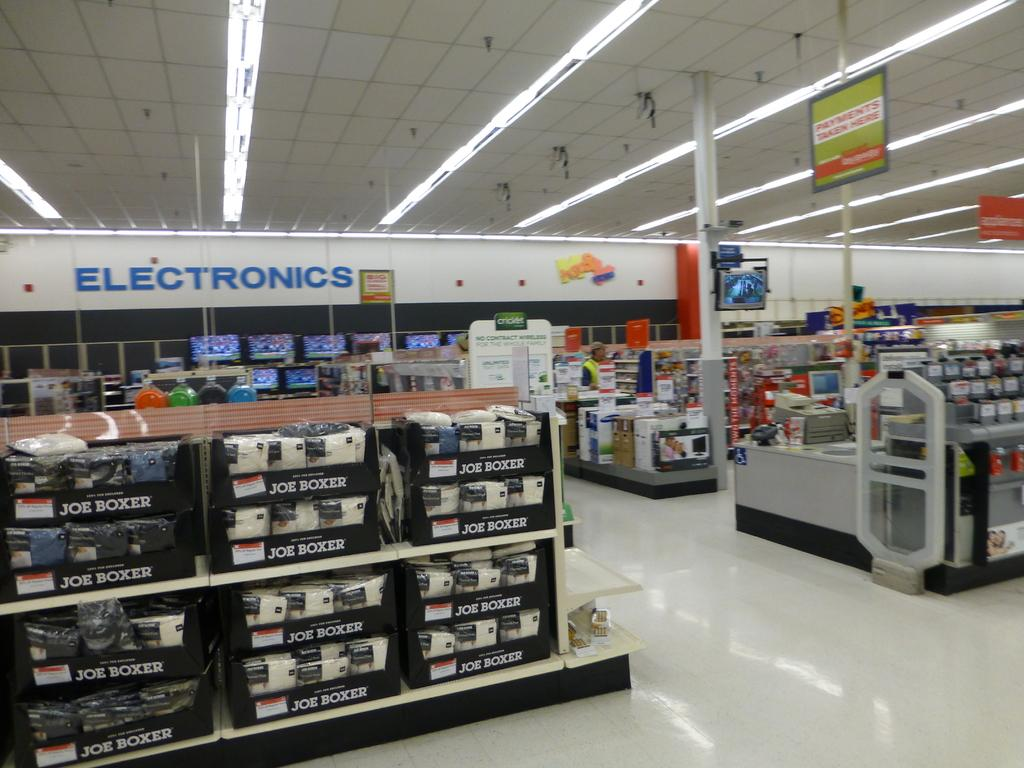Provide a one-sentence caption for the provided image. A sign over the Electronics section of the store is written in blue. 